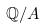<formula> <loc_0><loc_0><loc_500><loc_500>\mathbb { Q } / A</formula> 